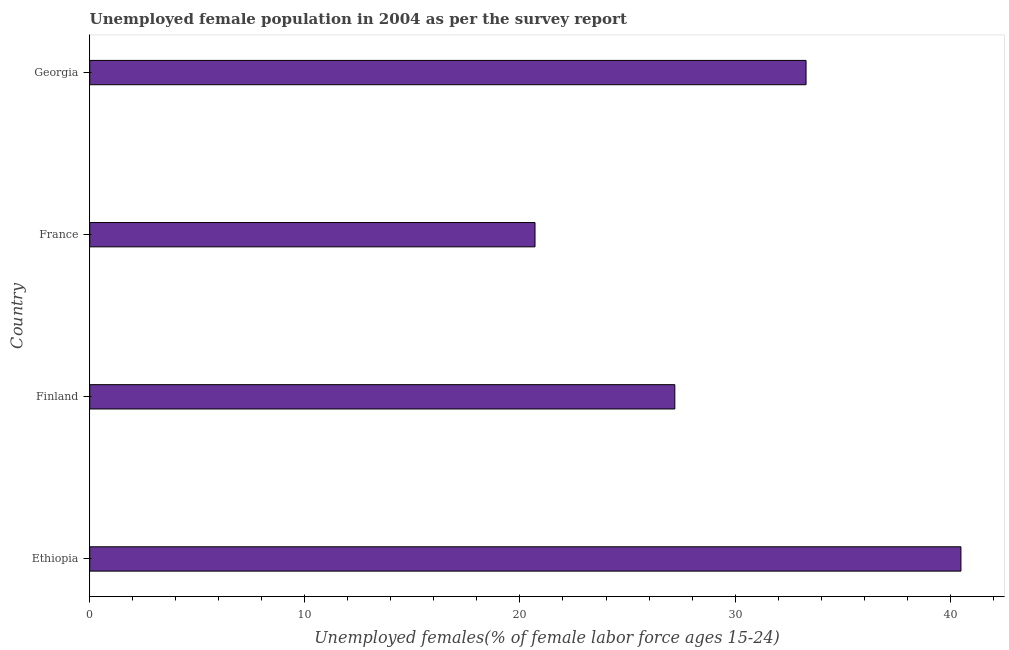Does the graph contain any zero values?
Your response must be concise. No. What is the title of the graph?
Your response must be concise. Unemployed female population in 2004 as per the survey report. What is the label or title of the X-axis?
Make the answer very short. Unemployed females(% of female labor force ages 15-24). What is the label or title of the Y-axis?
Provide a succinct answer. Country. What is the unemployed female youth in Ethiopia?
Provide a succinct answer. 40.5. Across all countries, what is the maximum unemployed female youth?
Provide a succinct answer. 40.5. Across all countries, what is the minimum unemployed female youth?
Provide a short and direct response. 20.7. In which country was the unemployed female youth maximum?
Provide a short and direct response. Ethiopia. In which country was the unemployed female youth minimum?
Provide a succinct answer. France. What is the sum of the unemployed female youth?
Provide a succinct answer. 121.7. What is the difference between the unemployed female youth in Ethiopia and France?
Provide a short and direct response. 19.8. What is the average unemployed female youth per country?
Your answer should be compact. 30.43. What is the median unemployed female youth?
Make the answer very short. 30.25. In how many countries, is the unemployed female youth greater than 26 %?
Offer a terse response. 3. What is the ratio of the unemployed female youth in Ethiopia to that in France?
Your response must be concise. 1.96. Is the unemployed female youth in Ethiopia less than that in Finland?
Your response must be concise. No. Is the difference between the unemployed female youth in Ethiopia and Georgia greater than the difference between any two countries?
Provide a short and direct response. No. Is the sum of the unemployed female youth in Ethiopia and France greater than the maximum unemployed female youth across all countries?
Keep it short and to the point. Yes. What is the difference between the highest and the lowest unemployed female youth?
Your answer should be very brief. 19.8. Are the values on the major ticks of X-axis written in scientific E-notation?
Provide a succinct answer. No. What is the Unemployed females(% of female labor force ages 15-24) in Ethiopia?
Make the answer very short. 40.5. What is the Unemployed females(% of female labor force ages 15-24) in Finland?
Offer a terse response. 27.2. What is the Unemployed females(% of female labor force ages 15-24) in France?
Offer a very short reply. 20.7. What is the Unemployed females(% of female labor force ages 15-24) in Georgia?
Keep it short and to the point. 33.3. What is the difference between the Unemployed females(% of female labor force ages 15-24) in Ethiopia and France?
Provide a short and direct response. 19.8. What is the ratio of the Unemployed females(% of female labor force ages 15-24) in Ethiopia to that in Finland?
Keep it short and to the point. 1.49. What is the ratio of the Unemployed females(% of female labor force ages 15-24) in Ethiopia to that in France?
Offer a very short reply. 1.96. What is the ratio of the Unemployed females(% of female labor force ages 15-24) in Ethiopia to that in Georgia?
Ensure brevity in your answer.  1.22. What is the ratio of the Unemployed females(% of female labor force ages 15-24) in Finland to that in France?
Give a very brief answer. 1.31. What is the ratio of the Unemployed females(% of female labor force ages 15-24) in Finland to that in Georgia?
Ensure brevity in your answer.  0.82. What is the ratio of the Unemployed females(% of female labor force ages 15-24) in France to that in Georgia?
Ensure brevity in your answer.  0.62. 